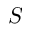Convert formula to latex. <formula><loc_0><loc_0><loc_500><loc_500>S</formula> 